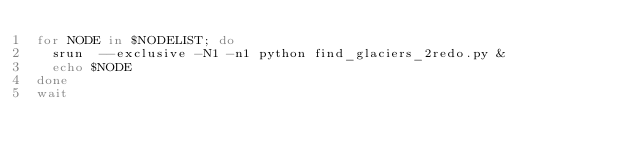<code> <loc_0><loc_0><loc_500><loc_500><_Bash_>for NODE in $NODELIST; do
  srun  --exclusive -N1 -n1 python find_glaciers_2redo.py &
  echo $NODE
done
wait</code> 